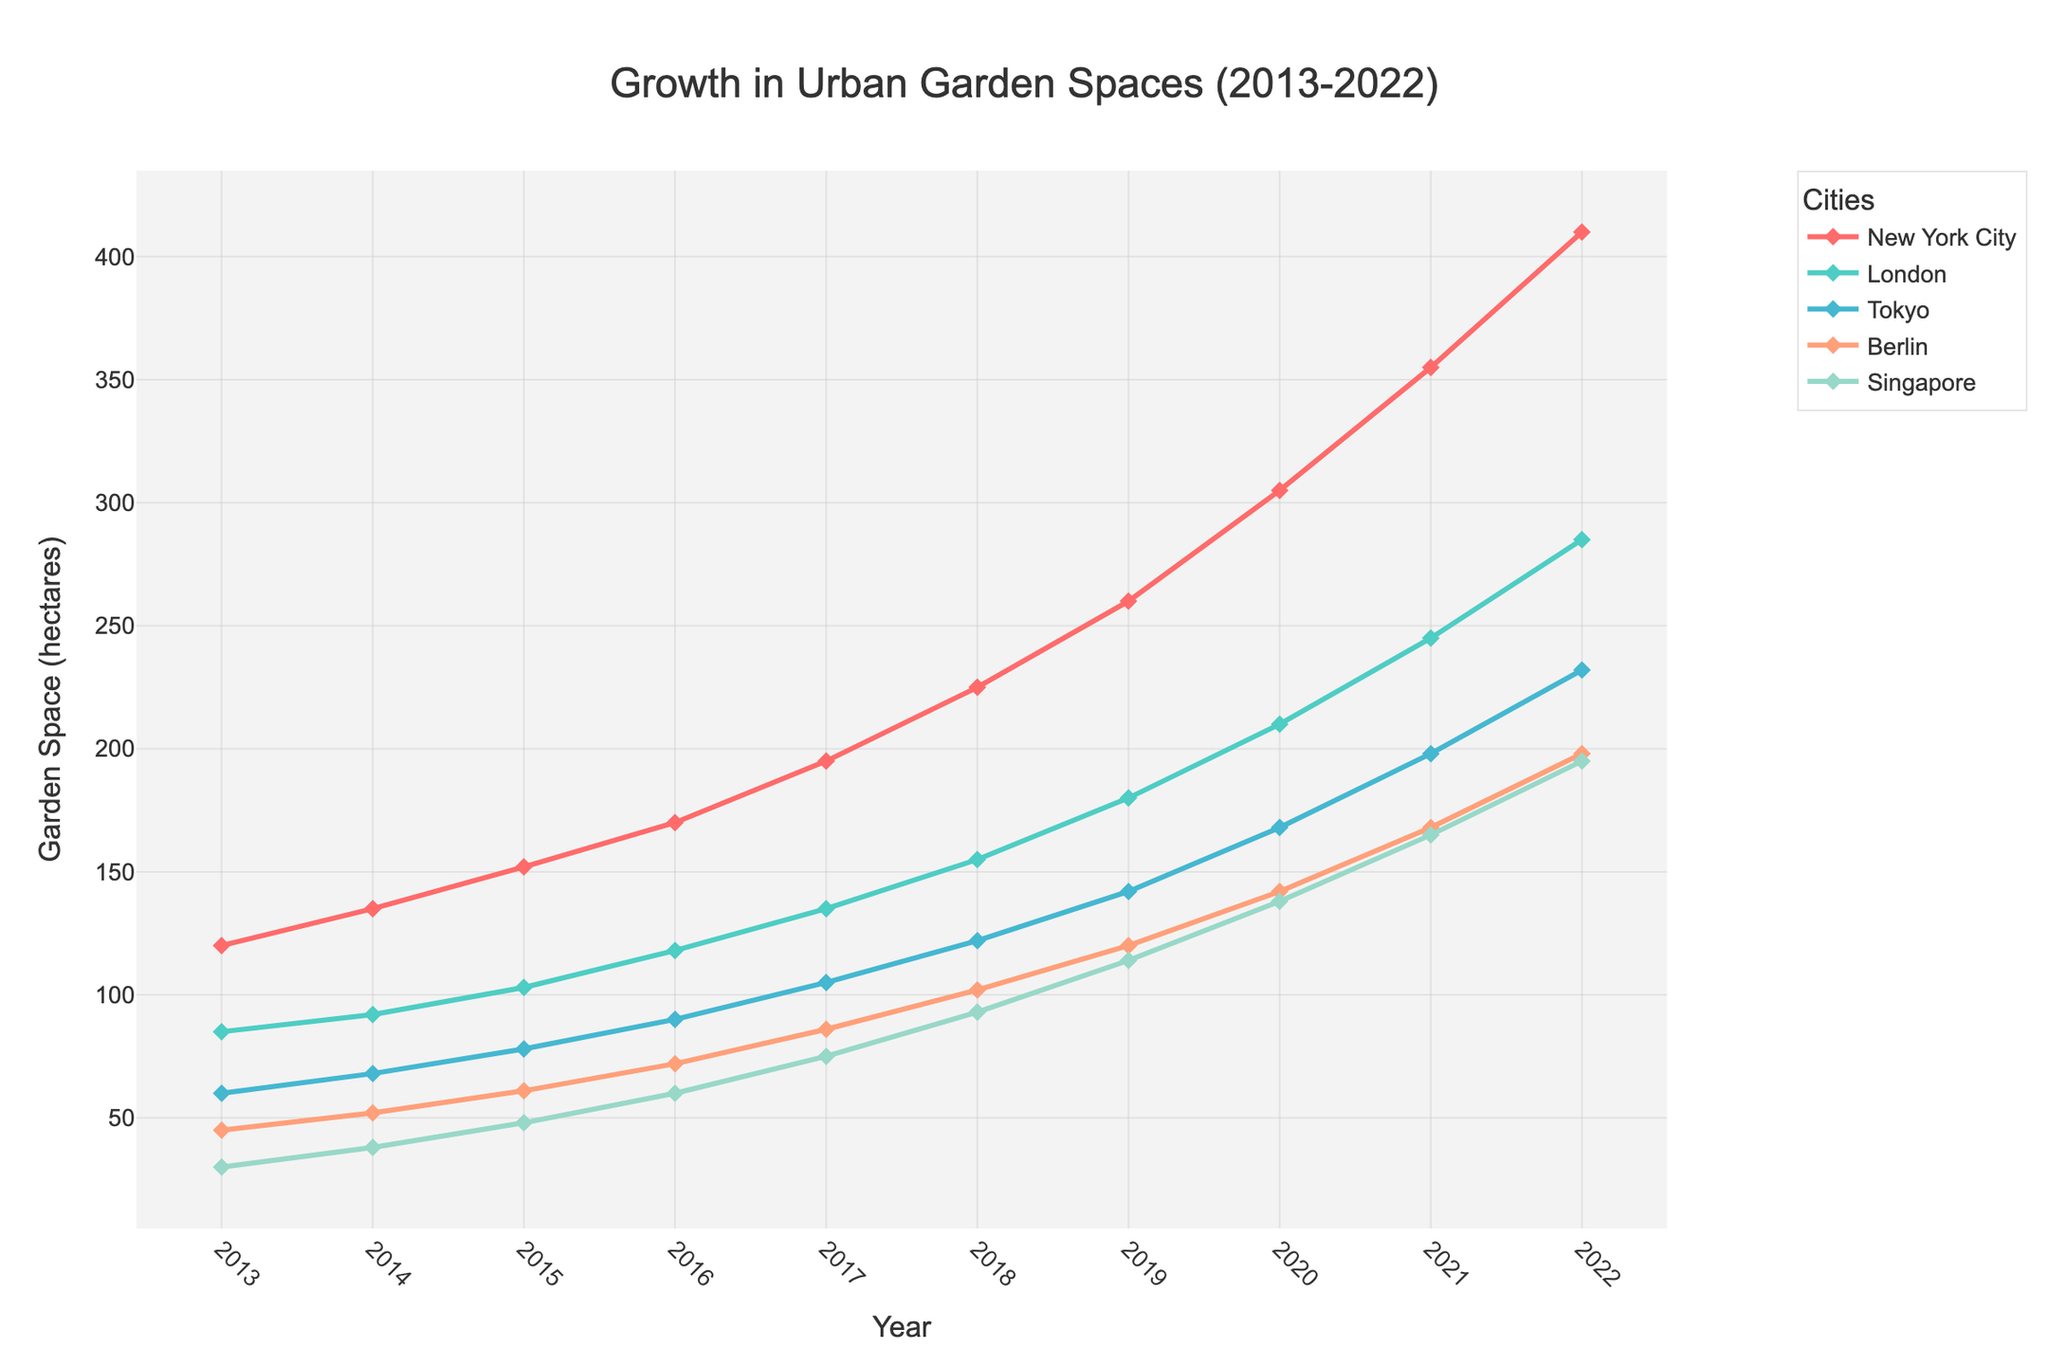What city showed the greatest increase in garden space from 2013 to 2022? To find the city with the greatest increase, calculate the difference in garden space between 2022 and 2013 for each city: NYC: 410-120=290, London: 285-85=200, Tokyo: 232-60=172, Berlin: 198-45=153, Singapore: 195-30=165. NYC has the greatest increase.
Answer: New York City How much garden space did Tokyo add from 2016 to 2020? Calculate the difference in garden space for Tokyo between 2020 and 2016: 168-90 = 78 hectares.
Answer: 78 hectares Which city had the least garden space in 2017? Check the figure for garden space values in 2017. Singapore had the least garden space at 75 hectares.
Answer: Singapore During which year did New York City surpass 200 hectares of garden space? Look for the year where New York City's garden space first exceeds 200. In 2018, New York City surpassed 200 hectares.
Answer: 2018 What was the average garden space for Berlin from 2013 to 2022? Sum Berlin’s garden spaces from 2013 to 2022 and divide by the number of years: (45+52+61+72+86+102+120+142+168+198)/10 = 104.6 hectares.
Answer: 104.6 hectares Which years show a significant increase in garden space for Singapore? Look for years with steep increases in Singapore's line. Significant increases are seen from 2018 to 2021.
Answer: 2018-2021 Compare the garden space growth rate between London and Tokyo from 2013 to 2022. Calculate the difference for London (285-85=200) and Tokyo (232-60=172), then compare these numbers. London's growth is 200 hectares, and Tokyo's is 172 hectares, so London had a higher growth rate.
Answer: London had a higher growth rate What's the trend for garden space in Berlin over the years? Observe the line for Berlin. The trend shows a consistent increase in garden space from 2013 to 2022.
Answer: Increasing trend What can be inferred about garden space in New York City versus Singapore by 2022? Compare the final 2022 values for New York City (410 hectares) and Singapore (195 hectares). New York City has significantly more garden space than Singapore in 2022.
Answer: NYC > Singapore 